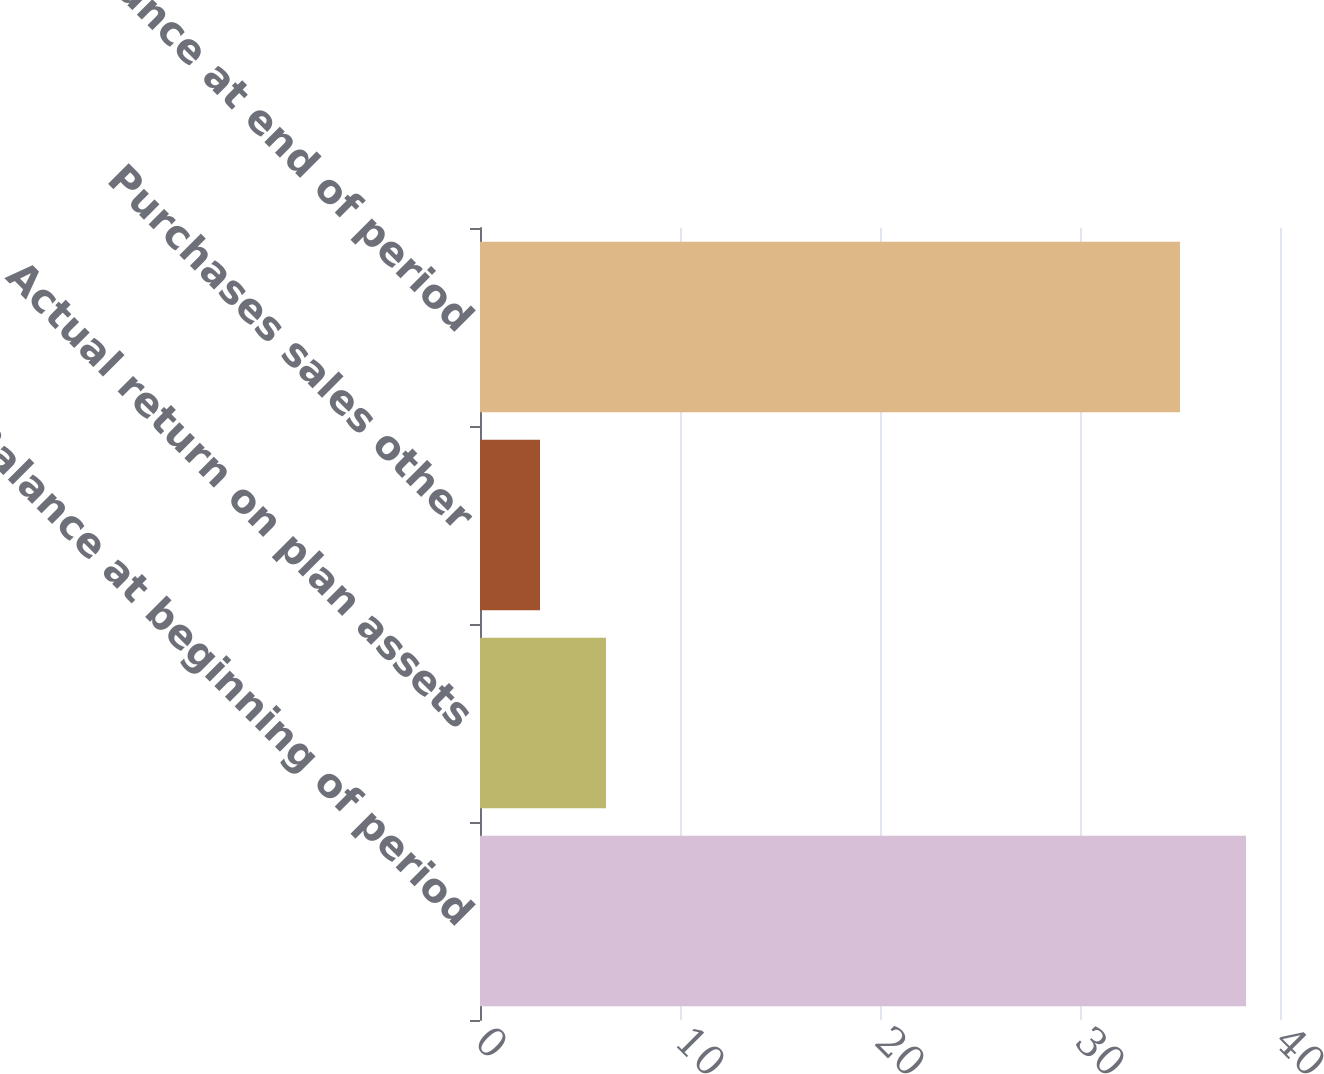Convert chart to OTSL. <chart><loc_0><loc_0><loc_500><loc_500><bar_chart><fcel>Balance at beginning of period<fcel>Actual return on plan assets<fcel>Purchases sales other<fcel>Balance at end of period<nl><fcel>38.3<fcel>6.3<fcel>3<fcel>35<nl></chart> 